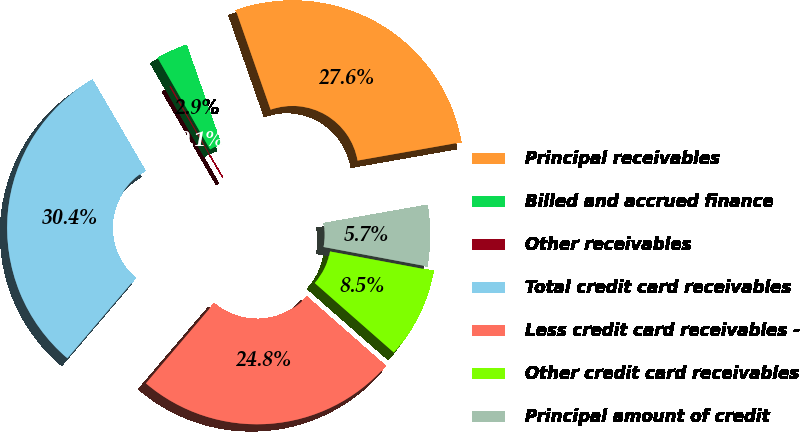<chart> <loc_0><loc_0><loc_500><loc_500><pie_chart><fcel>Principal receivables<fcel>Billed and accrued finance<fcel>Other receivables<fcel>Total credit card receivables<fcel>Less credit card receivables -<fcel>Other credit card receivables<fcel>Principal amount of credit<nl><fcel>27.57%<fcel>2.92%<fcel>0.11%<fcel>30.38%<fcel>24.76%<fcel>8.53%<fcel>5.73%<nl></chart> 